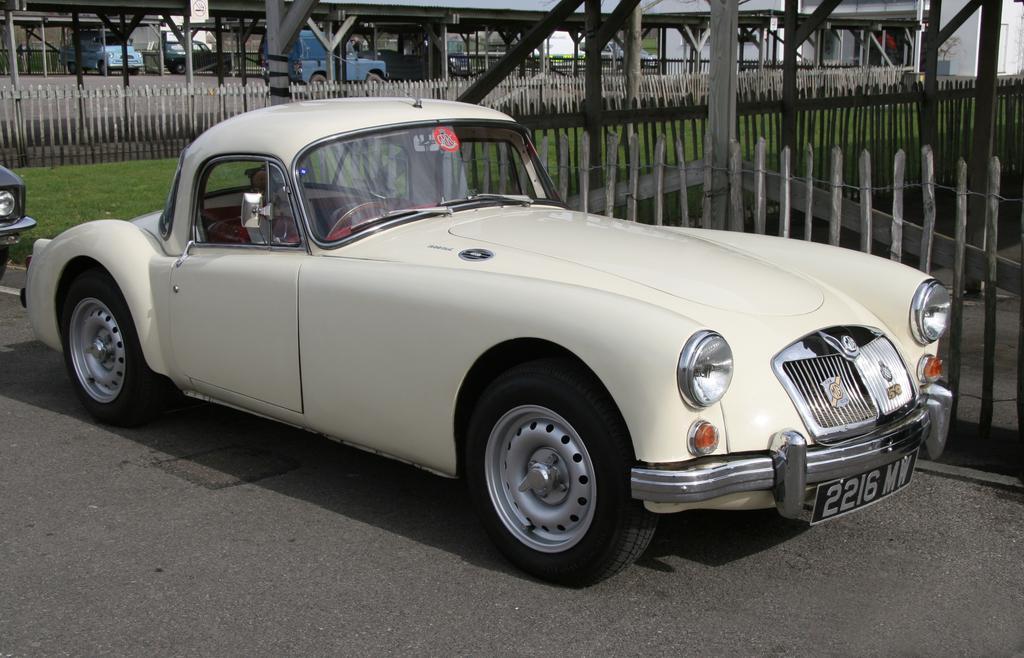How would you summarize this image in a sentence or two? In this image, we can see a white car is parked on the road. Background we can see fencing, poles, grass, few vehicles, wall. 